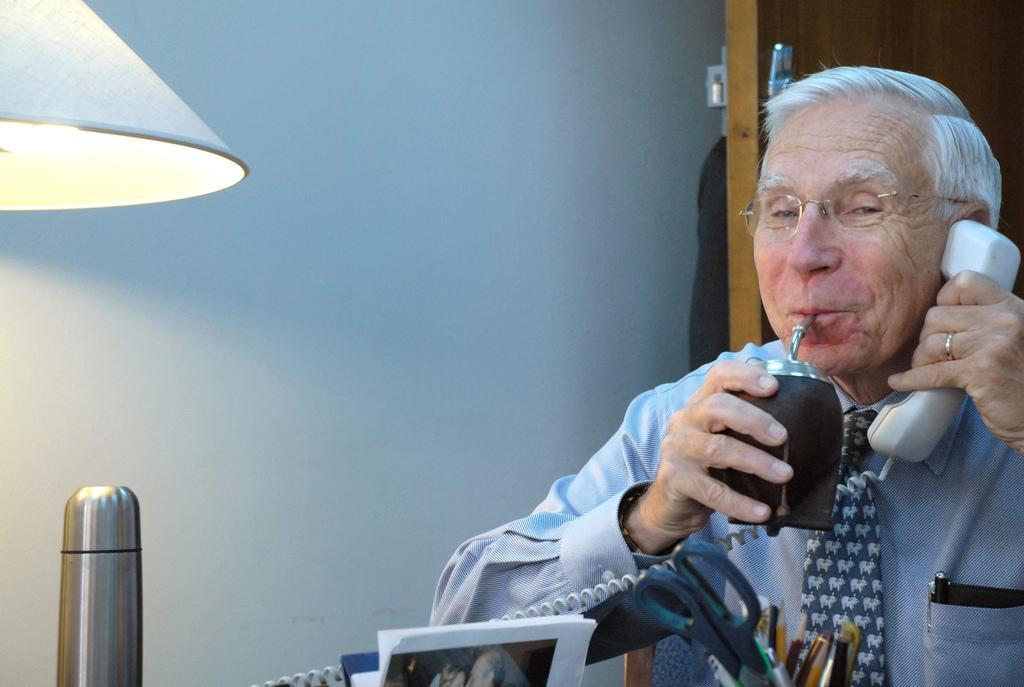Can you describe this image briefly? In this image, I can see a man holding a telephone receiver and a cup with a zipper. At the bottom of the image, I can see papers, flask, scissors, pencils and pens. In the top left corner of the image, there is a lamp shade. In the background, I can see a wall and a door. 